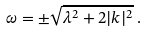<formula> <loc_0><loc_0><loc_500><loc_500>\omega = \pm \sqrt { \lambda ^ { 2 } + 2 | k | ^ { 2 } } \, .</formula> 